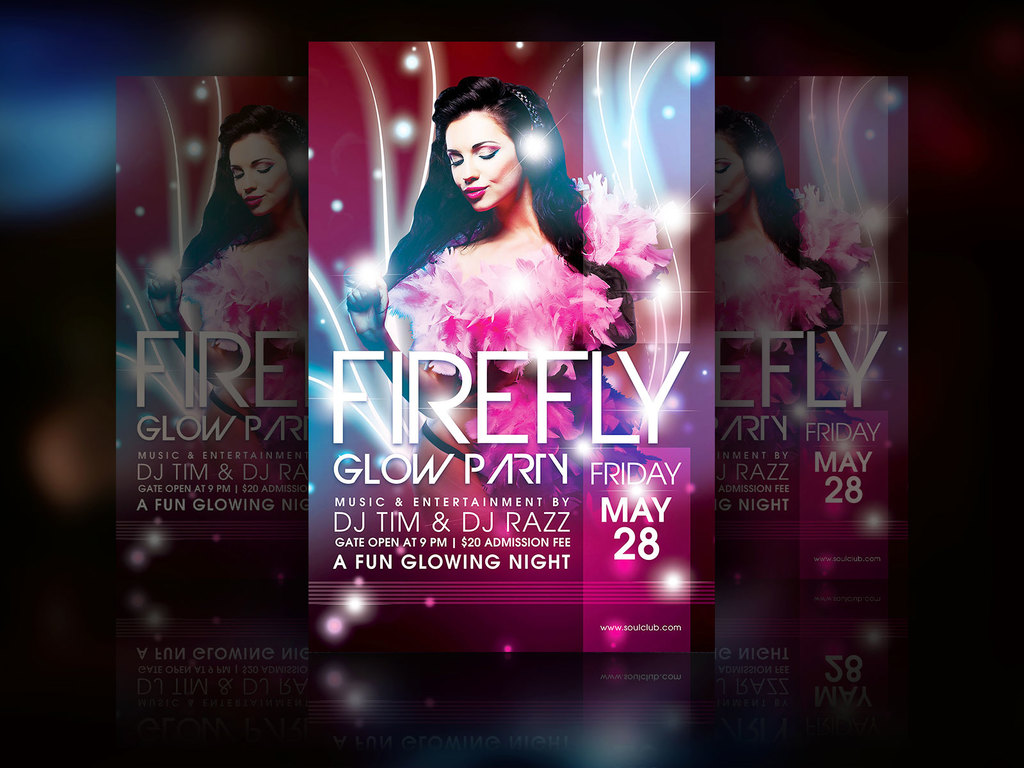What does the text on the image reveal about the type of event being advertised? The text indicates that this is a 'Firefly Glow Party' with music and entertainment provided by DJ Tim and DJ Razz. It suggests a lively, engaging night event focused on fun and music, which will occur on a Friday night, specifically May 28th. The event also has a cover charge as indicated by the 'Admission Fee' text. 